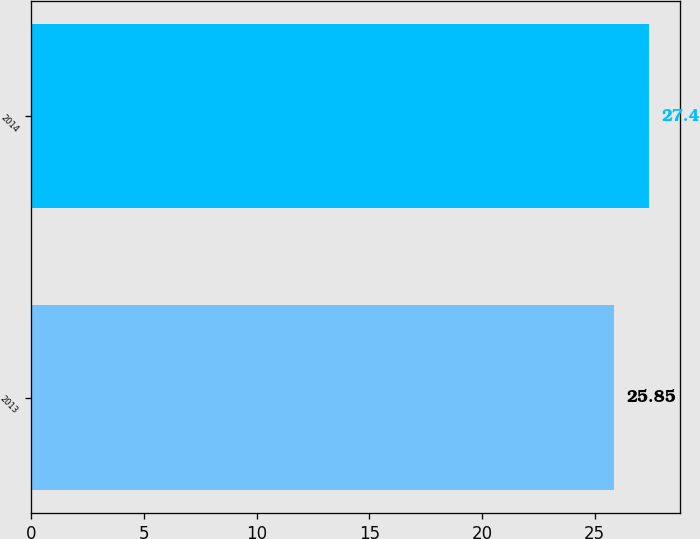<chart> <loc_0><loc_0><loc_500><loc_500><bar_chart><fcel>2013<fcel>2014<nl><fcel>25.85<fcel>27.4<nl></chart> 